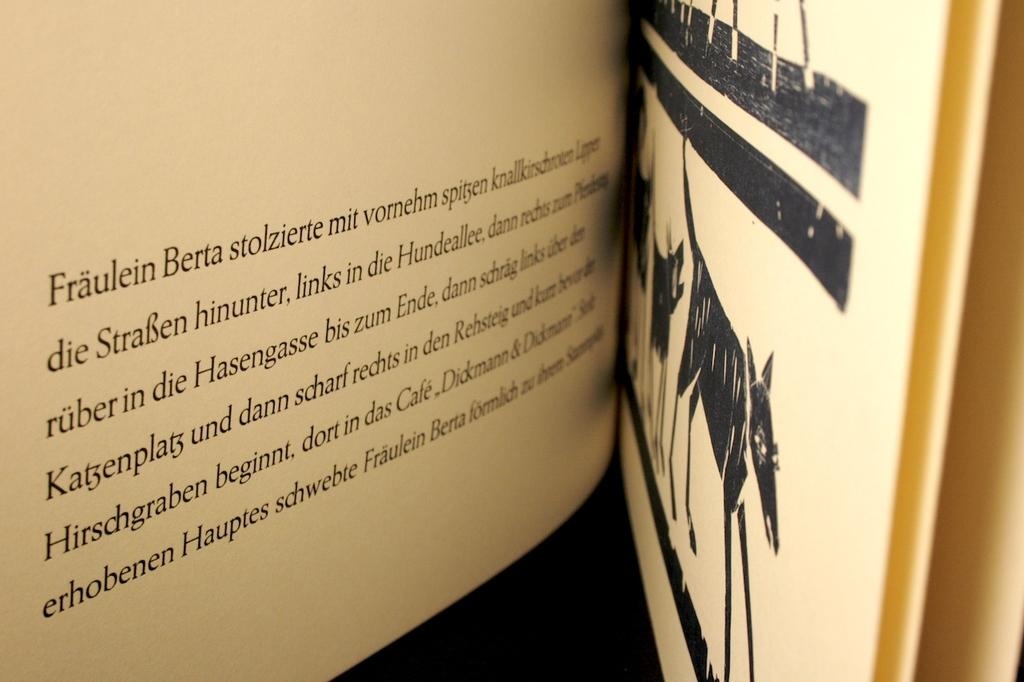<image>
Provide a brief description of the given image. A book is open to a page that begins with the words "Fraulein Berta stolzierte mit vornehm." 